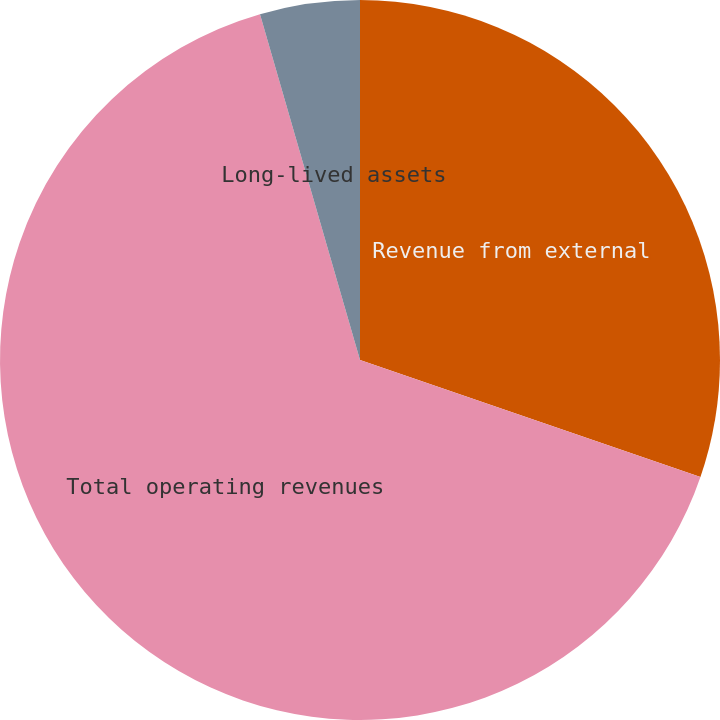<chart> <loc_0><loc_0><loc_500><loc_500><pie_chart><fcel>Revenue from external<fcel>Total operating revenues<fcel>Long-lived assets<nl><fcel>30.27%<fcel>65.25%<fcel>4.48%<nl></chart> 